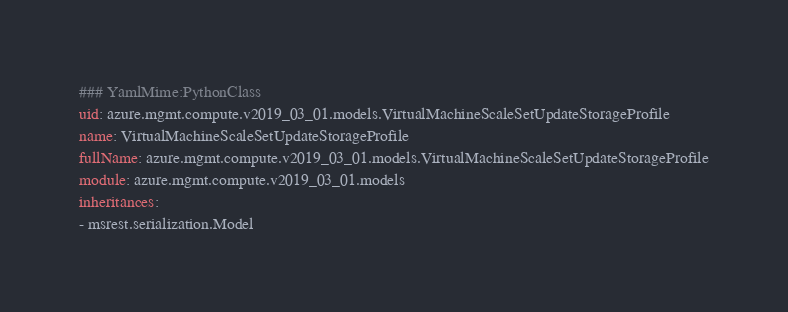<code> <loc_0><loc_0><loc_500><loc_500><_YAML_>### YamlMime:PythonClass
uid: azure.mgmt.compute.v2019_03_01.models.VirtualMachineScaleSetUpdateStorageProfile
name: VirtualMachineScaleSetUpdateStorageProfile
fullName: azure.mgmt.compute.v2019_03_01.models.VirtualMachineScaleSetUpdateStorageProfile
module: azure.mgmt.compute.v2019_03_01.models
inheritances:
- msrest.serialization.Model</code> 